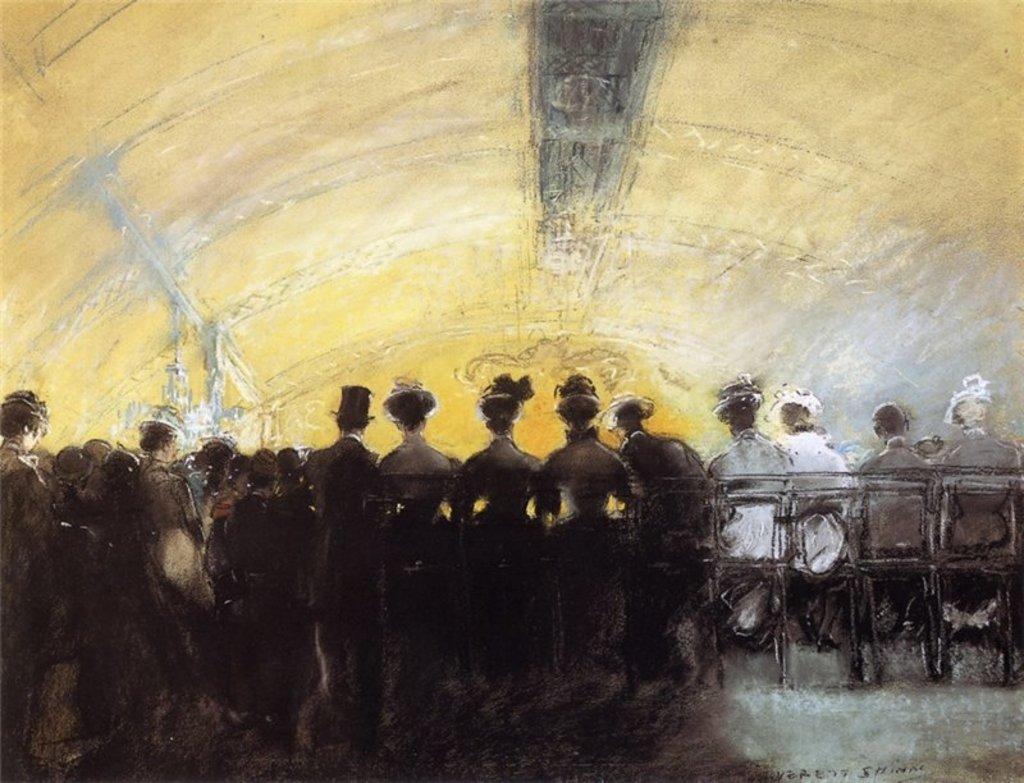Please provide a concise description of this image. In this image we can see a painting of a group of persons. Some persons are sitting on chairs. 